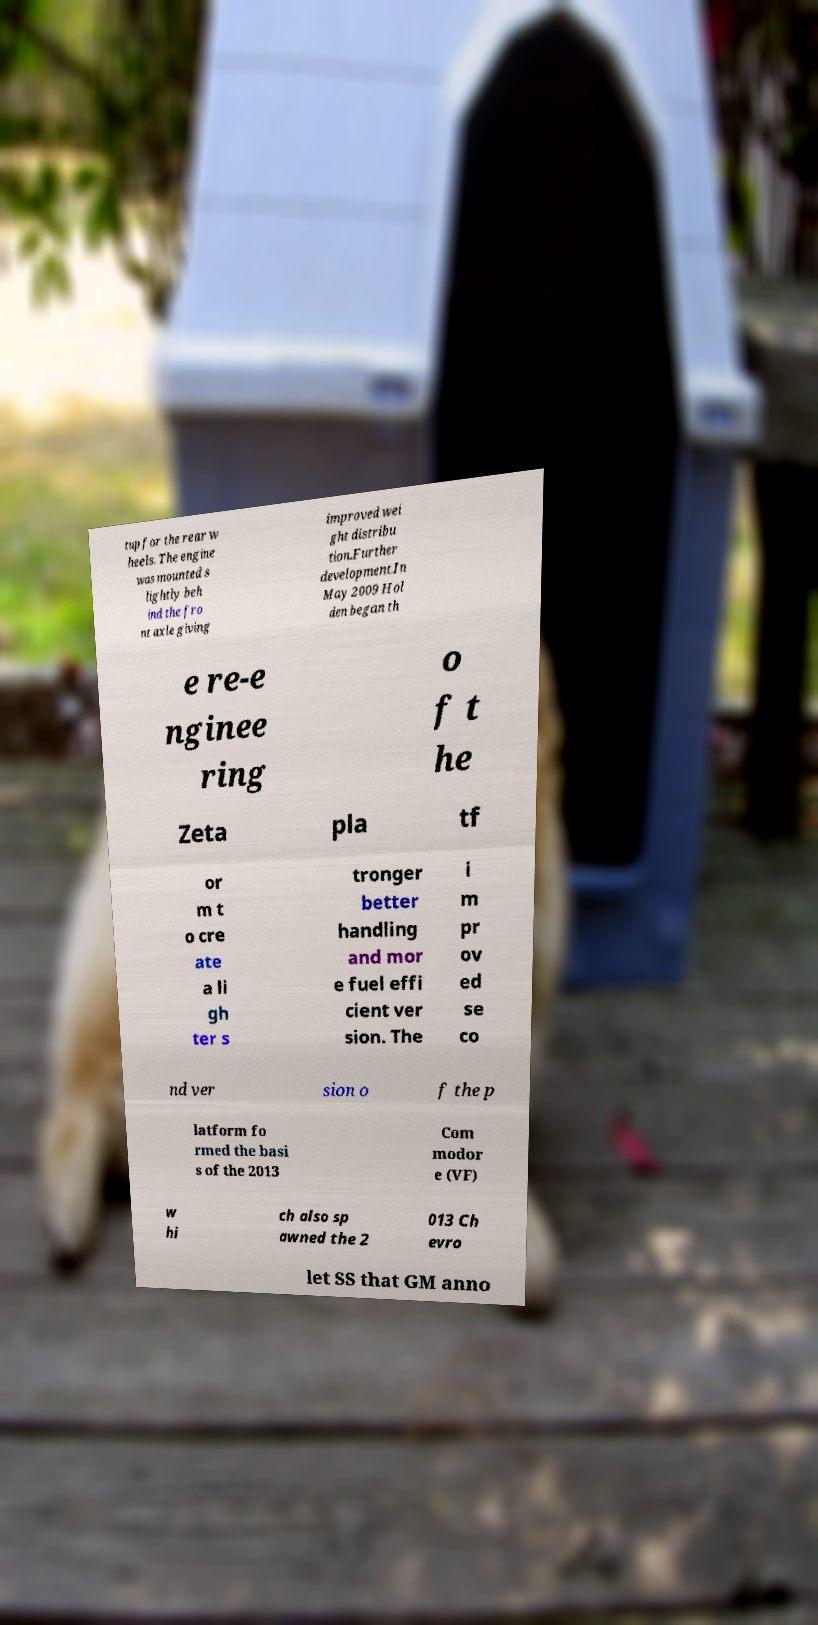Can you accurately transcribe the text from the provided image for me? tup for the rear w heels. The engine was mounted s lightly beh ind the fro nt axle giving improved wei ght distribu tion.Further development.In May 2009 Hol den began th e re-e nginee ring o f t he Zeta pla tf or m t o cre ate a li gh ter s tronger better handling and mor e fuel effi cient ver sion. The i m pr ov ed se co nd ver sion o f the p latform fo rmed the basi s of the 2013 Com modor e (VF) w hi ch also sp awned the 2 013 Ch evro let SS that GM anno 